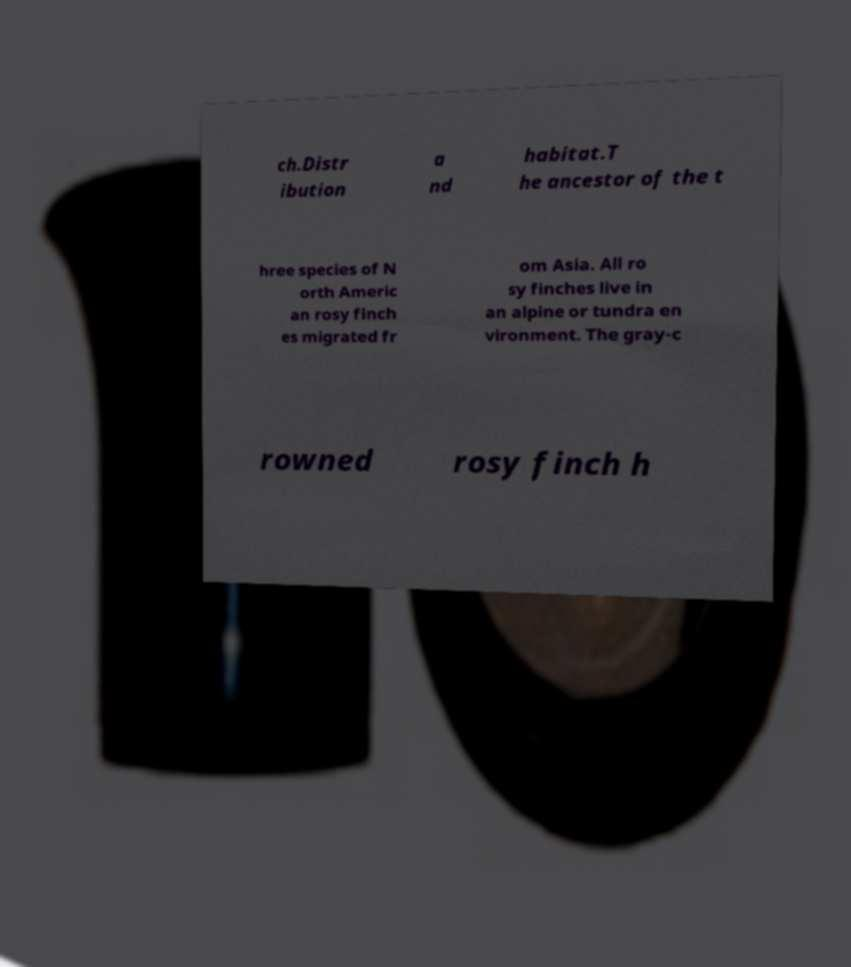Please read and relay the text visible in this image. What does it say? ch.Distr ibution a nd habitat.T he ancestor of the t hree species of N orth Americ an rosy finch es migrated fr om Asia. All ro sy finches live in an alpine or tundra en vironment. The gray-c rowned rosy finch h 